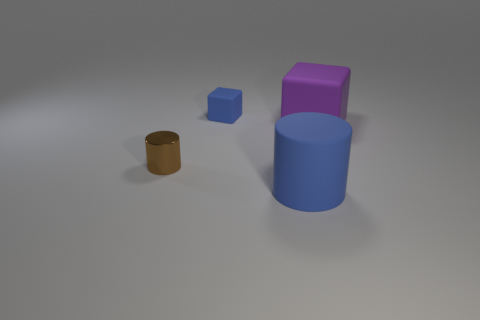What textures are visible on the objects presented in the image? The objects exhibit two types of texture: the small blue block has a matte finish, whereas both the cylinder and the metallic-looking object to the left have reflective surfaces, creating a slight sheen on their exteriors. 